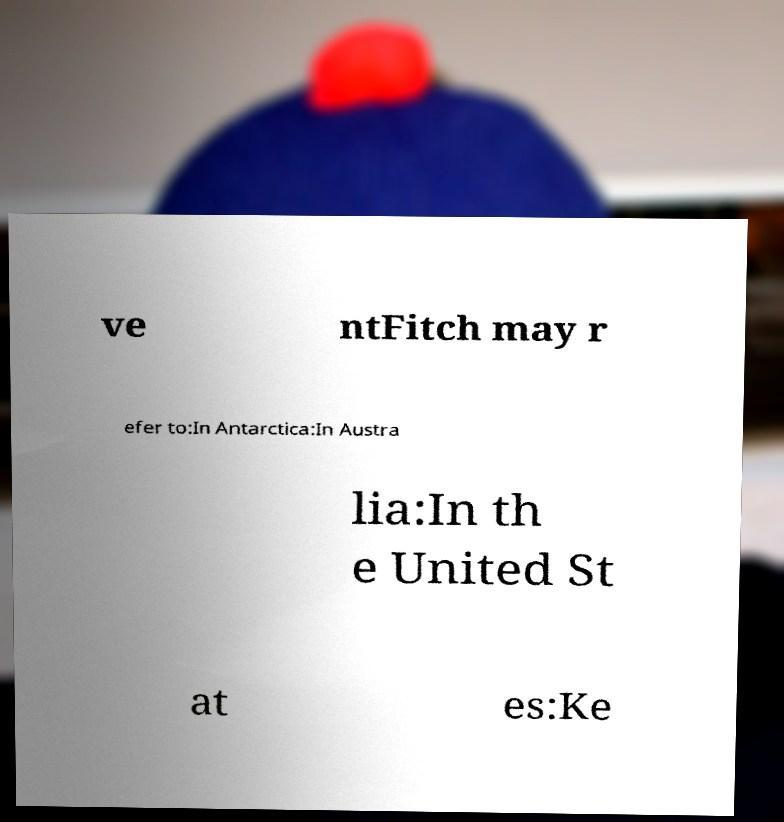Could you assist in decoding the text presented in this image and type it out clearly? ve ntFitch may r efer to:In Antarctica:In Austra lia:In th e United St at es:Ke 